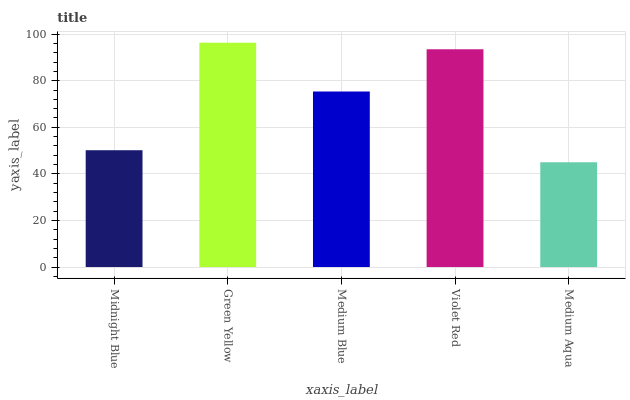Is Medium Aqua the minimum?
Answer yes or no. Yes. Is Green Yellow the maximum?
Answer yes or no. Yes. Is Medium Blue the minimum?
Answer yes or no. No. Is Medium Blue the maximum?
Answer yes or no. No. Is Green Yellow greater than Medium Blue?
Answer yes or no. Yes. Is Medium Blue less than Green Yellow?
Answer yes or no. Yes. Is Medium Blue greater than Green Yellow?
Answer yes or no. No. Is Green Yellow less than Medium Blue?
Answer yes or no. No. Is Medium Blue the high median?
Answer yes or no. Yes. Is Medium Blue the low median?
Answer yes or no. Yes. Is Violet Red the high median?
Answer yes or no. No. Is Violet Red the low median?
Answer yes or no. No. 